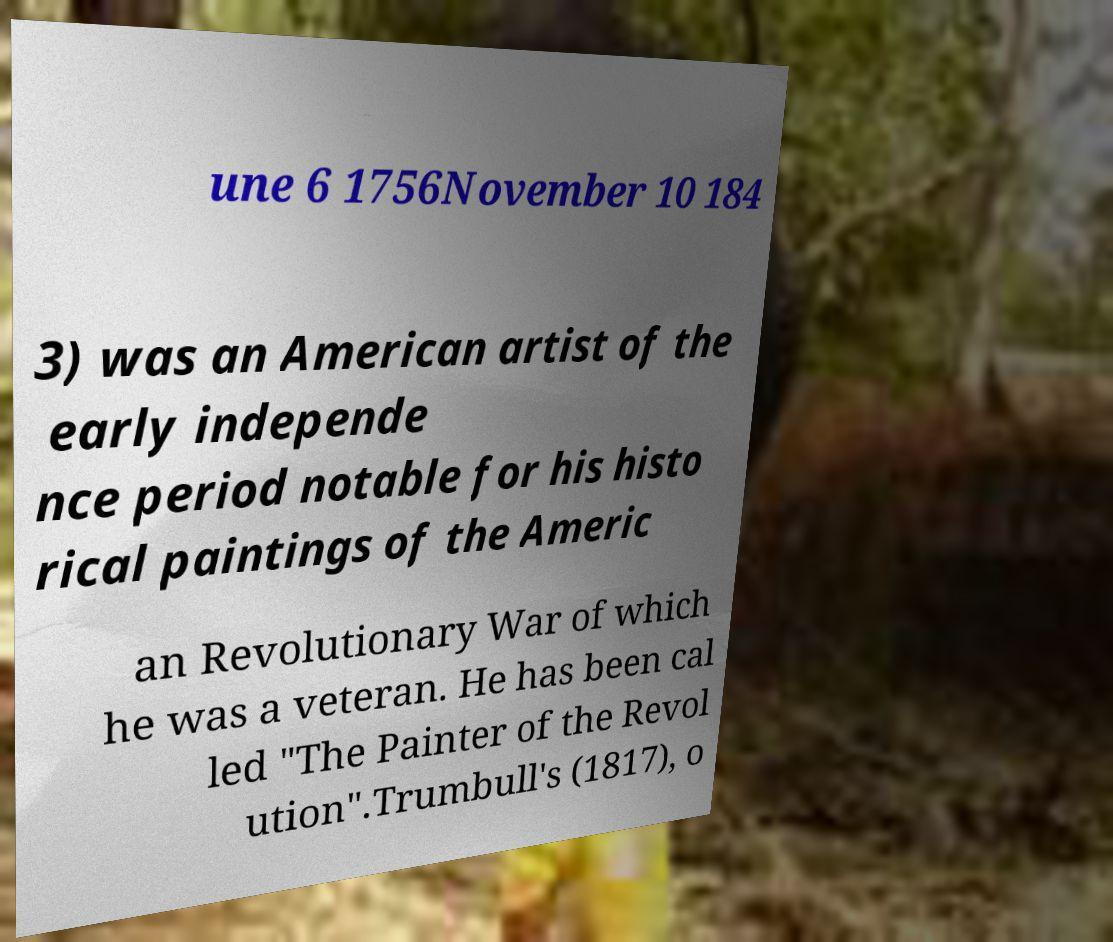What messages or text are displayed in this image? I need them in a readable, typed format. une 6 1756November 10 184 3) was an American artist of the early independe nce period notable for his histo rical paintings of the Americ an Revolutionary War of which he was a veteran. He has been cal led "The Painter of the Revol ution".Trumbull's (1817), o 